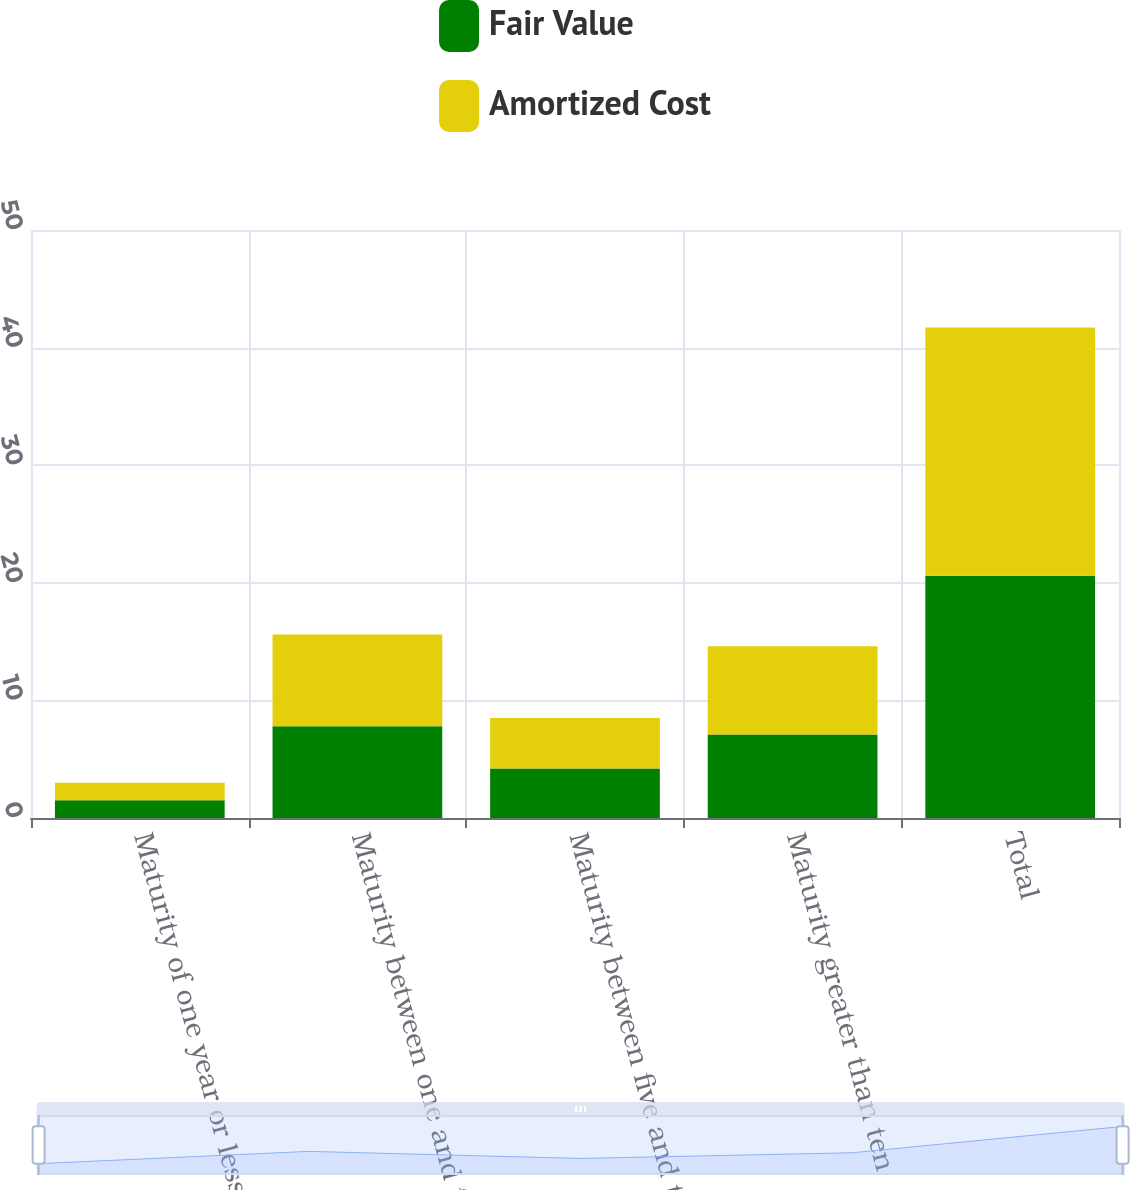<chart> <loc_0><loc_0><loc_500><loc_500><stacked_bar_chart><ecel><fcel>Maturity of one year or less<fcel>Maturity between one and five<fcel>Maturity between five and ten<fcel>Maturity greater than ten<fcel>Total<nl><fcel>Fair Value<fcel>1.5<fcel>7.8<fcel>4.2<fcel>7.1<fcel>20.6<nl><fcel>Amortized Cost<fcel>1.5<fcel>7.8<fcel>4.3<fcel>7.5<fcel>21.1<nl></chart> 